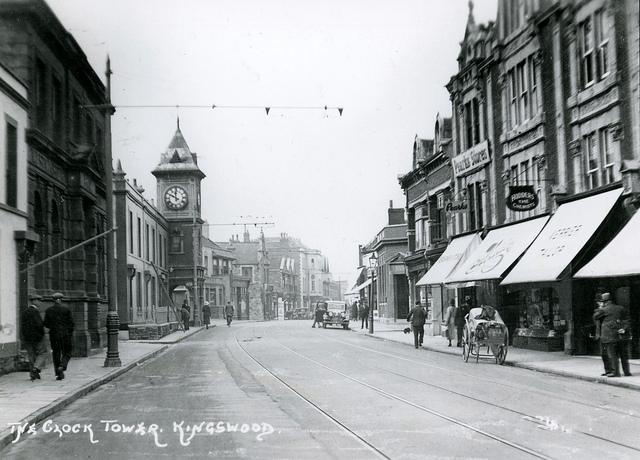What's on the line across the buildings?
Answer briefly. Birds. Was this photo recently taken?
Concise answer only. No. Is there a clock tower in the background?
Quick response, please. Yes. What country is this city in?
Give a very brief answer. England. 